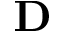<formula> <loc_0><loc_0><loc_500><loc_500>D</formula> 